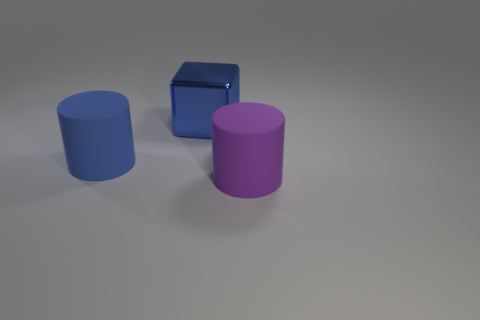Add 2 blocks. How many objects exist? 5 Subtract all cylinders. How many objects are left? 1 Add 1 big blue metal things. How many big blue metal things are left? 2 Add 2 large objects. How many large objects exist? 5 Subtract 0 purple spheres. How many objects are left? 3 Subtract all red matte blocks. Subtract all purple cylinders. How many objects are left? 2 